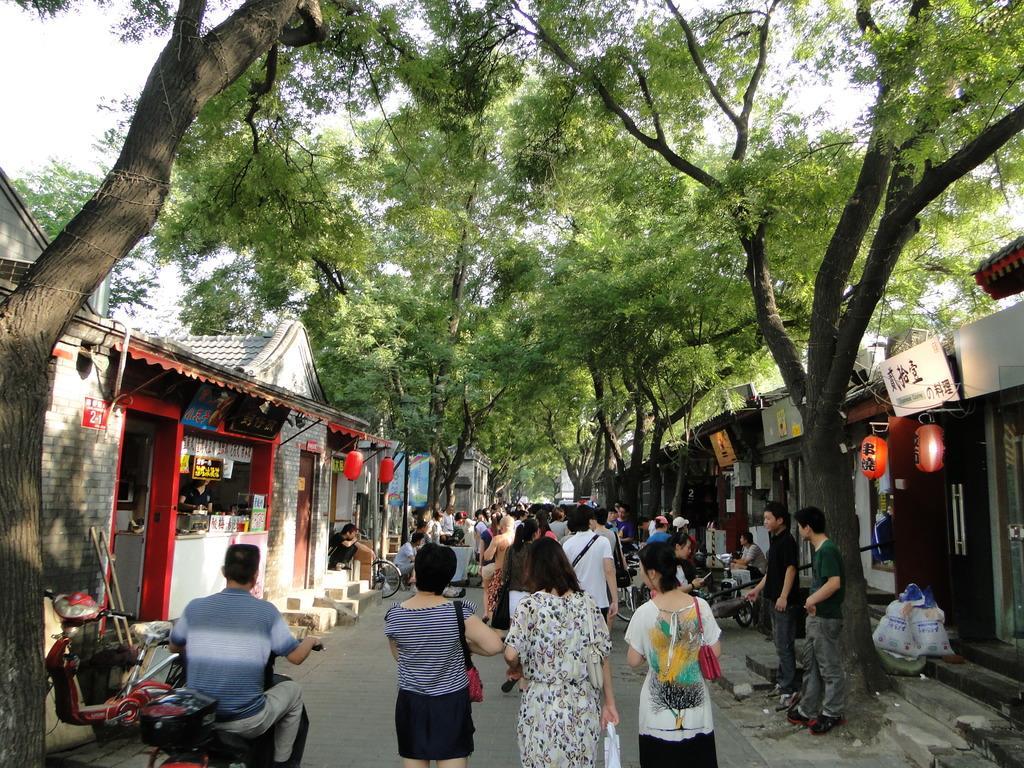How would you summarize this image in a sentence or two? In the center of the image we can see people standing and some of them are walking. On the left there is a man sitting on the bike. In the background there are trees, sheds, boards, lights and sky. 